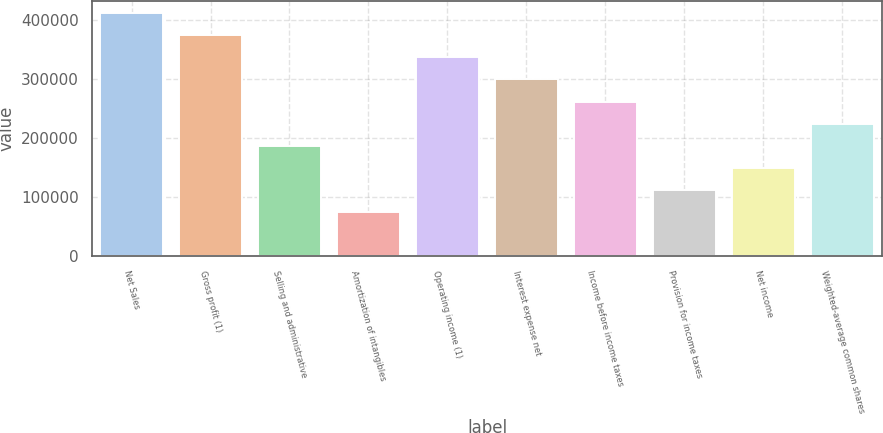Convert chart to OTSL. <chart><loc_0><loc_0><loc_500><loc_500><bar_chart><fcel>Net Sales<fcel>Gross profit (1)<fcel>Selling and administrative<fcel>Amortization of intangibles<fcel>Operating income (1)<fcel>Interest expense net<fcel>Income before income taxes<fcel>Provision for income taxes<fcel>Net income<fcel>Weighted-average common shares<nl><fcel>411678<fcel>374253<fcel>187127<fcel>74851.2<fcel>336828<fcel>299403<fcel>261977<fcel>112276<fcel>149702<fcel>224552<nl></chart> 